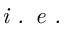Convert formula to latex. <formula><loc_0><loc_0><loc_500><loc_500>i . e .</formula> 